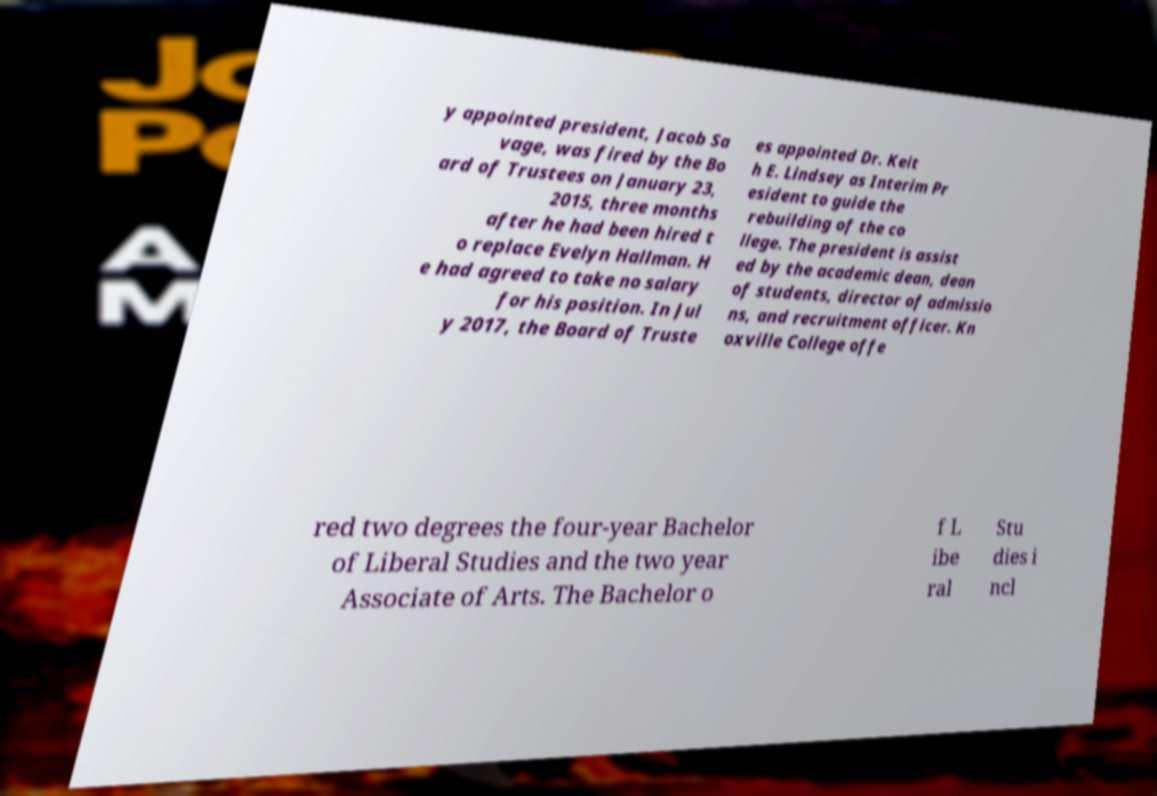What messages or text are displayed in this image? I need them in a readable, typed format. y appointed president, Jacob Sa vage, was fired by the Bo ard of Trustees on January 23, 2015, three months after he had been hired t o replace Evelyn Hallman. H e had agreed to take no salary for his position. In Jul y 2017, the Board of Truste es appointed Dr. Keit h E. Lindsey as Interim Pr esident to guide the rebuilding of the co llege. The president is assist ed by the academic dean, dean of students, director of admissio ns, and recruitment officer. Kn oxville College offe red two degrees the four-year Bachelor of Liberal Studies and the two year Associate of Arts. The Bachelor o f L ibe ral Stu dies i ncl 